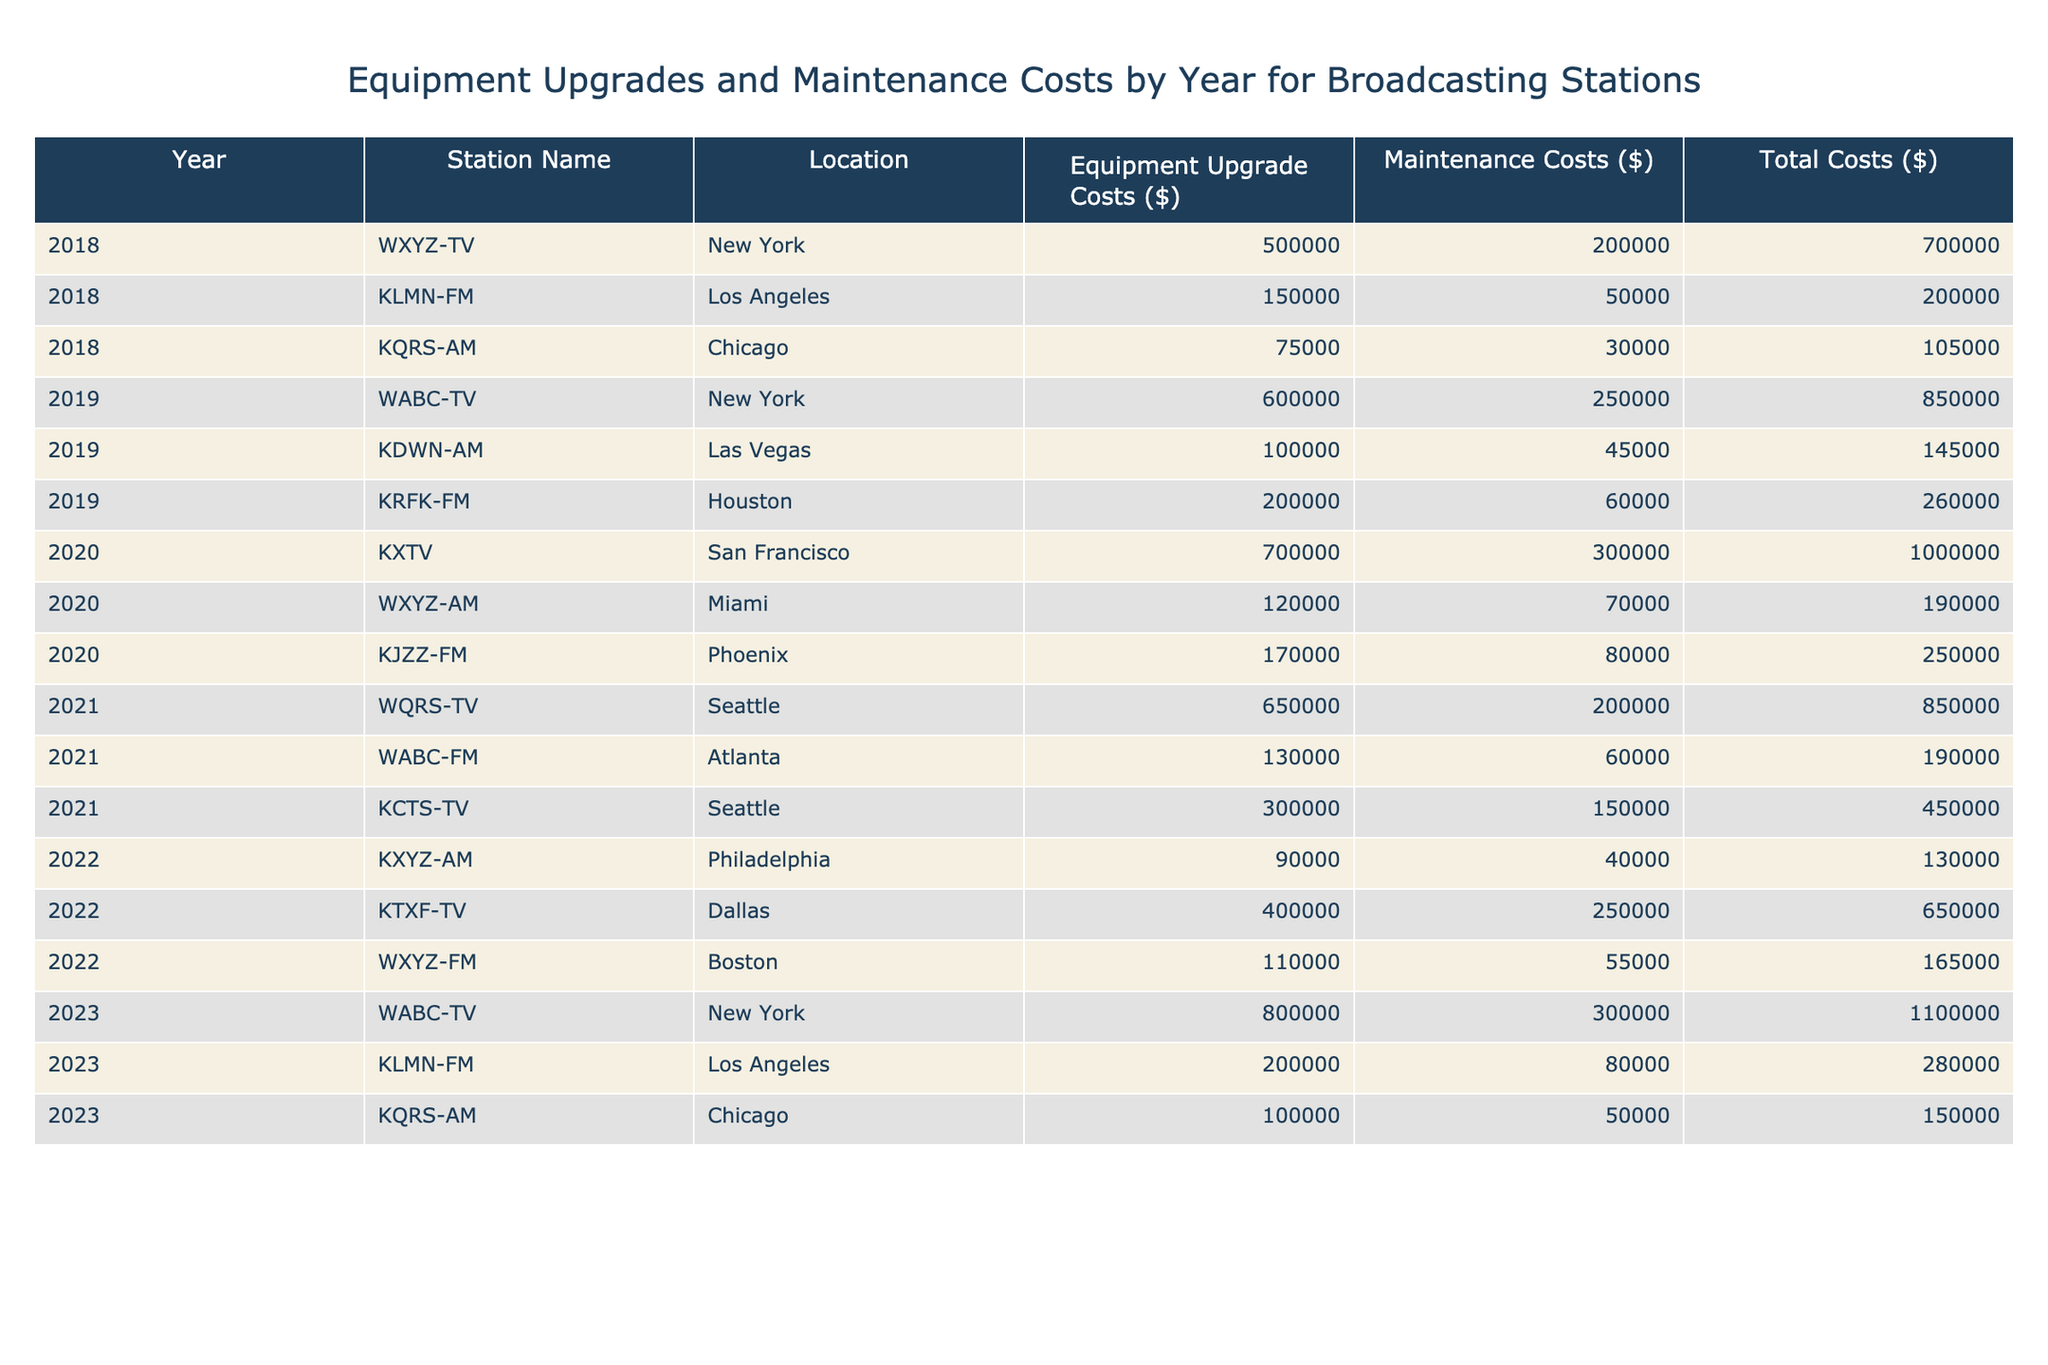What was the total equipment upgrade cost for WXYZ-TV in 2018? According to the table, WXYZ-TV's equipment upgrade cost in 2018 is listed as $500,000.
Answer: $500,000 What is the total maintenance cost for all stations in 2020? We can find the maintenance costs for 2020 in the table: $300,000 (KXTV) + $70,000 (WXYZ-AM) + $80,000 (KJZZ-FM) = $450,000.
Answer: $450,000 Is the total cost for KLMN-FM in 2019 greater than $200,000? The total cost for KLMN-FM in 2019 is $145,000, which is less than $200,000.
Answer: No Which station had the highest total costs in 2023? In 2023, WABC-TV had total costs of $1,100,000, which is the highest compared to KLMN-FM ($280,000) and KQRS-AM ($150,000).
Answer: WABC-TV What is the average maintenance cost for all stations across the years represented? The total maintenance costs can be summed up: 200,000 + 250,000 + 300,000 + 200,000 + 60,000 + 70,000 + 150,000 + 40,000 + 250,000 + 80,000 + 50,000 = 1,760,000. There are 11 data points, so the average is 1,760,000 / 11 = 160,000.
Answer: $160,000 In which year did KQRS-AM have its highest maintenance costs? Upon reviewing the maintenance costs for KQRS-AM: 30,000 (2018), 0 (2019), 0 (2020), 0 (2021), 0 (2022), and 50,000 (2023), the highest is 50,000 in 2023.
Answer: 2023 What is the difference in total costs for WXYZ-TV between 2018 and 2023? The total cost for WXYZ-TV in 2018 is $700,000 and in 2023 is $1,100,000. The difference is $1,100,000 - $700,000 = $400,000.
Answer: $400,000 How many stations are represented in the table for the year 2021? The table lists three stations for the year 2021: WQRS-TV, WABC-FM, and KCTS-TV. Therefore, there are 3 stations.
Answer: 3 Which location had the lowest total costs in 2019? The total costs for 2019 are: WABC-TV ($850,000), KDWN-AM ($145,000), and KRFK-FM ($260,000). KDWN-AM has the lowest total costs of $145,000 in Las Vegas.
Answer: Las Vegas What is the total equipment upgrade cost for all stations in the year 2022? The equipment upgrade costs for 2022 are summed as follows: $90,000 (KXYZ-AM) + $400,000 (KTXF-TV) + $110,000 (WXYZ-FM) = $600,000.
Answer: $600,000 